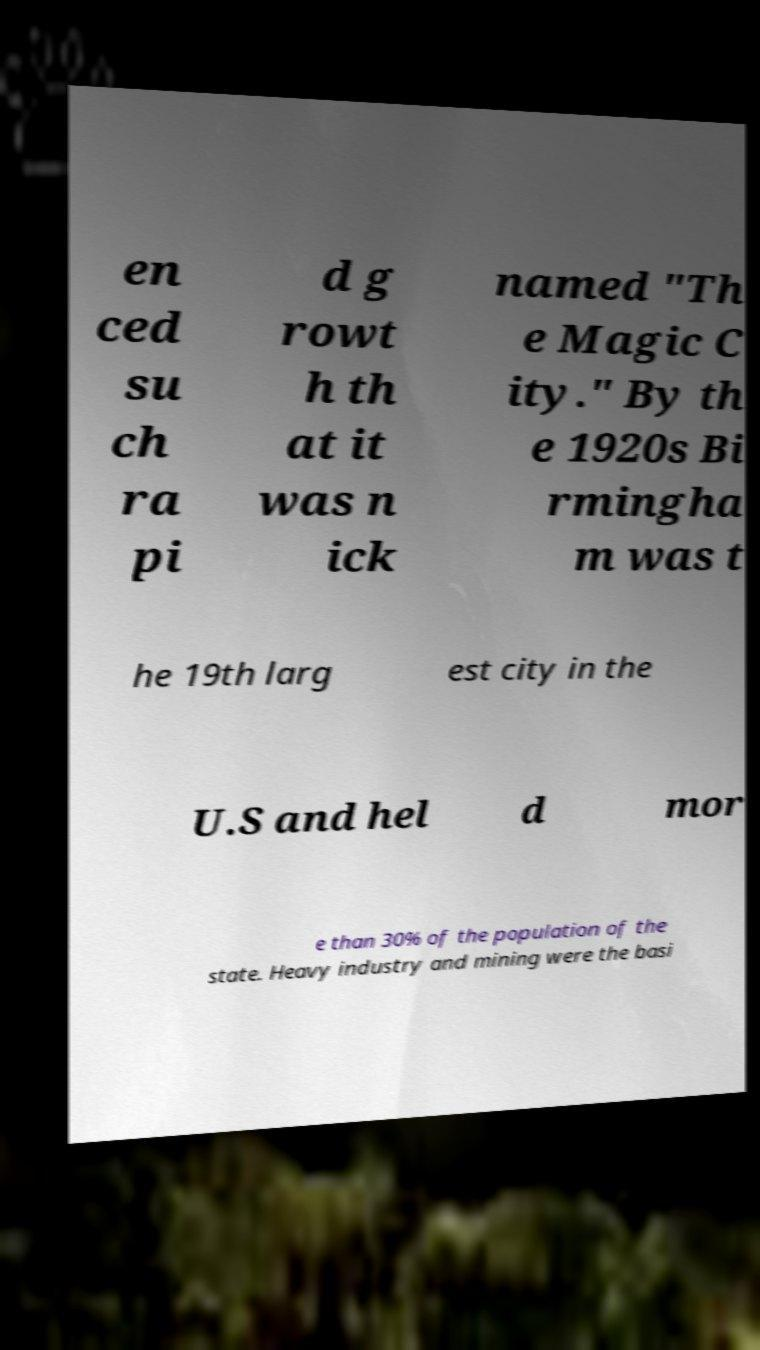Please identify and transcribe the text found in this image. en ced su ch ra pi d g rowt h th at it was n ick named "Th e Magic C ity." By th e 1920s Bi rmingha m was t he 19th larg est city in the U.S and hel d mor e than 30% of the population of the state. Heavy industry and mining were the basi 